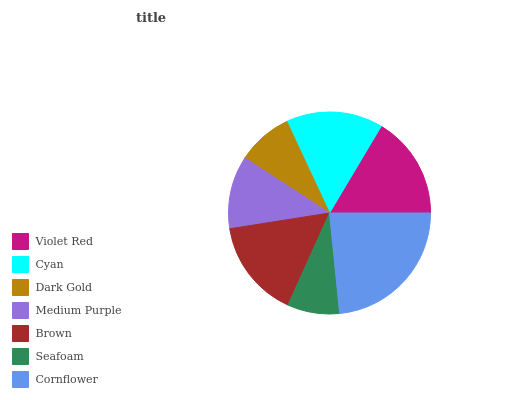Is Seafoam the minimum?
Answer yes or no. Yes. Is Cornflower the maximum?
Answer yes or no. Yes. Is Cyan the minimum?
Answer yes or no. No. Is Cyan the maximum?
Answer yes or no. No. Is Violet Red greater than Cyan?
Answer yes or no. Yes. Is Cyan less than Violet Red?
Answer yes or no. Yes. Is Cyan greater than Violet Red?
Answer yes or no. No. Is Violet Red less than Cyan?
Answer yes or no. No. Is Cyan the high median?
Answer yes or no. Yes. Is Cyan the low median?
Answer yes or no. Yes. Is Dark Gold the high median?
Answer yes or no. No. Is Seafoam the low median?
Answer yes or no. No. 